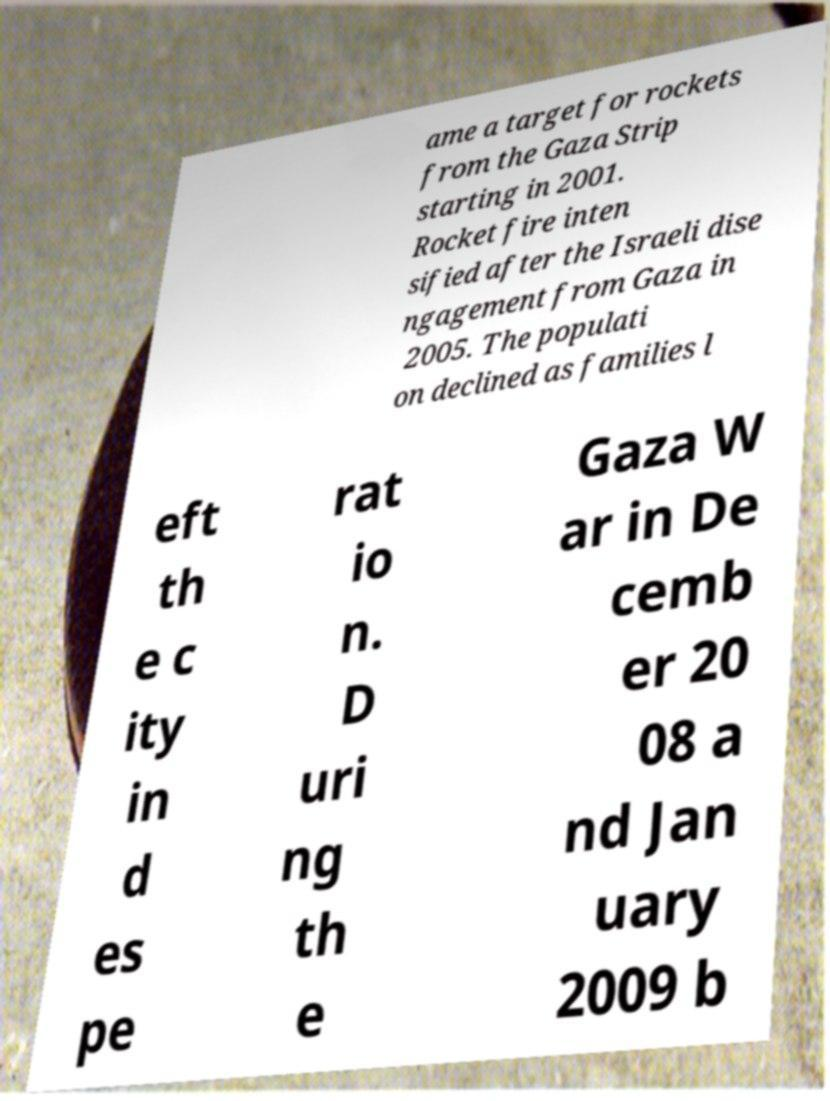For documentation purposes, I need the text within this image transcribed. Could you provide that? ame a target for rockets from the Gaza Strip starting in 2001. Rocket fire inten sified after the Israeli dise ngagement from Gaza in 2005. The populati on declined as families l eft th e c ity in d es pe rat io n. D uri ng th e Gaza W ar in De cemb er 20 08 a nd Jan uary 2009 b 